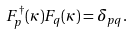<formula> <loc_0><loc_0><loc_500><loc_500>F _ { p } ^ { \dagger } ( \kappa ) F _ { q } ( \kappa ) = \delta _ { p q } .</formula> 